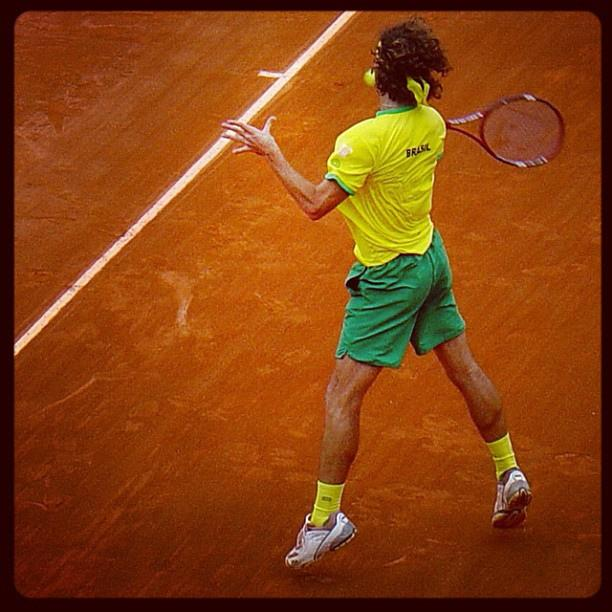What is this man doing? Please explain your reasoning. return ball. The man is hitting the ball. 